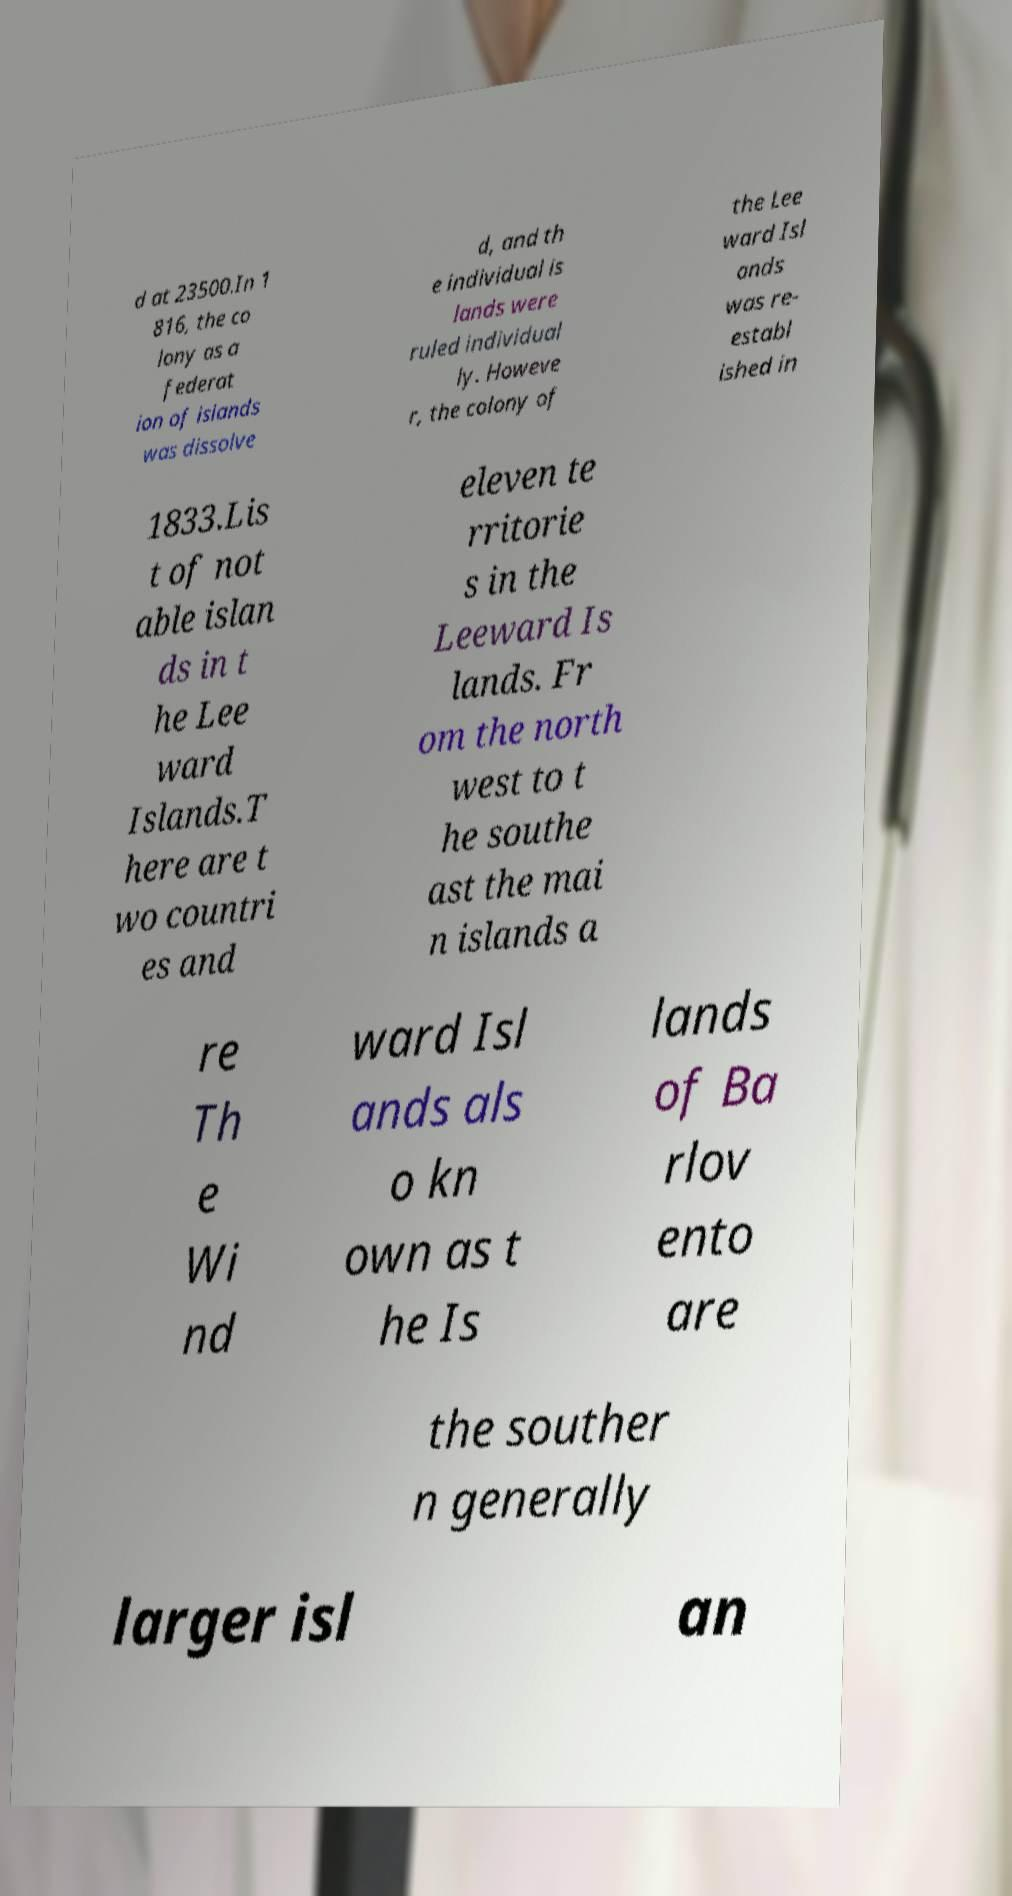Can you accurately transcribe the text from the provided image for me? d at 23500.In 1 816, the co lony as a federat ion of islands was dissolve d, and th e individual is lands were ruled individual ly. Howeve r, the colony of the Lee ward Isl ands was re- establ ished in 1833.Lis t of not able islan ds in t he Lee ward Islands.T here are t wo countri es and eleven te rritorie s in the Leeward Is lands. Fr om the north west to t he southe ast the mai n islands a re Th e Wi nd ward Isl ands als o kn own as t he Is lands of Ba rlov ento are the souther n generally larger isl an 